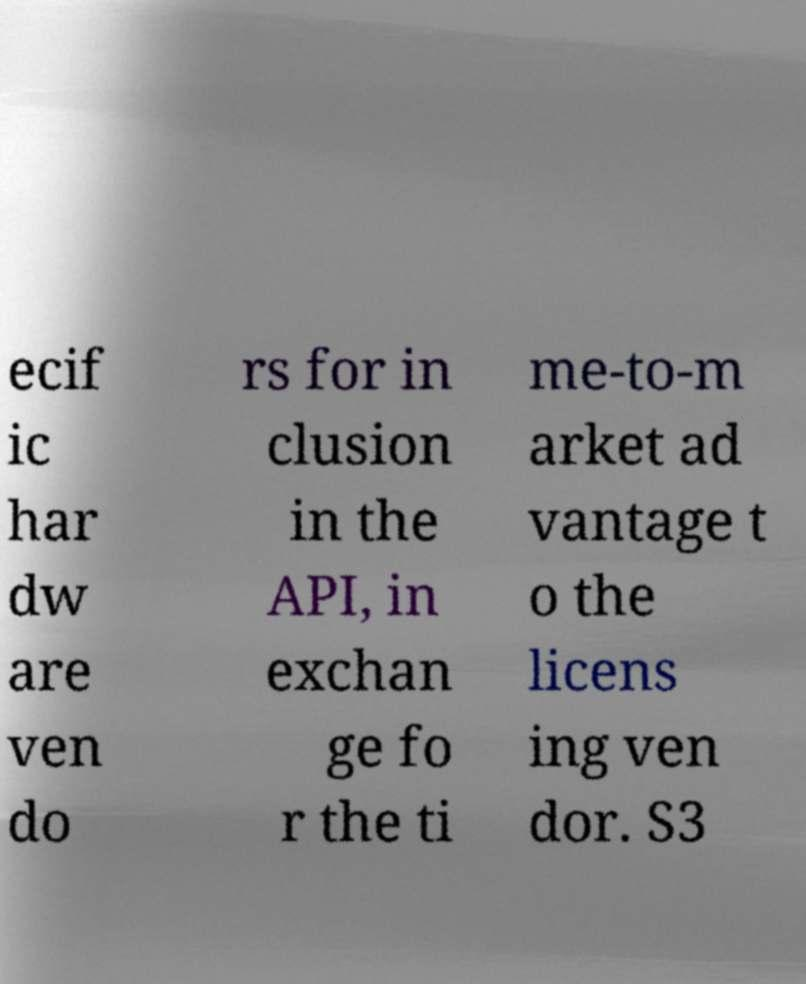Can you accurately transcribe the text from the provided image for me? ecif ic har dw are ven do rs for in clusion in the API, in exchan ge fo r the ti me-to-m arket ad vantage t o the licens ing ven dor. S3 